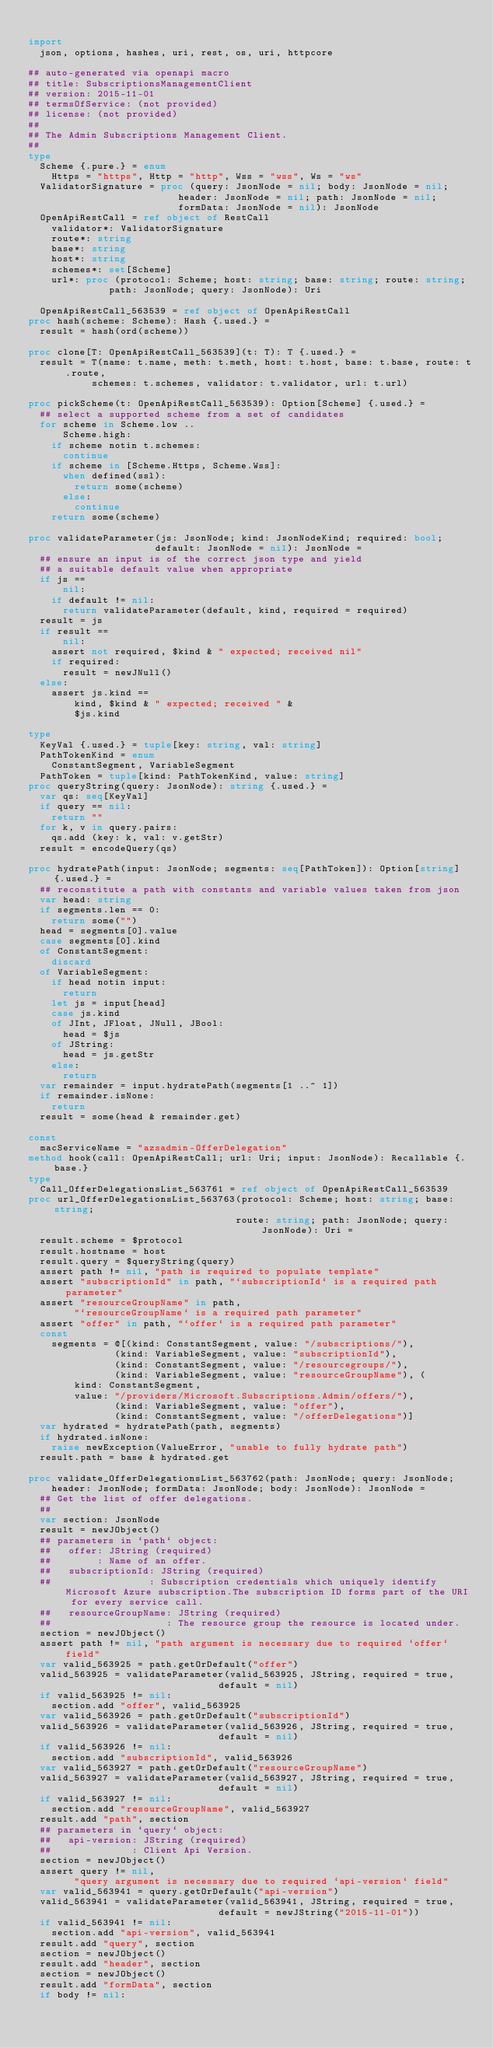<code> <loc_0><loc_0><loc_500><loc_500><_Nim_>
import
  json, options, hashes, uri, rest, os, uri, httpcore

## auto-generated via openapi macro
## title: SubscriptionsManagementClient
## version: 2015-11-01
## termsOfService: (not provided)
## license: (not provided)
## 
## The Admin Subscriptions Management Client.
## 
type
  Scheme {.pure.} = enum
    Https = "https", Http = "http", Wss = "wss", Ws = "ws"
  ValidatorSignature = proc (query: JsonNode = nil; body: JsonNode = nil;
                          header: JsonNode = nil; path: JsonNode = nil;
                          formData: JsonNode = nil): JsonNode
  OpenApiRestCall = ref object of RestCall
    validator*: ValidatorSignature
    route*: string
    base*: string
    host*: string
    schemes*: set[Scheme]
    url*: proc (protocol: Scheme; host: string; base: string; route: string;
              path: JsonNode; query: JsonNode): Uri

  OpenApiRestCall_563539 = ref object of OpenApiRestCall
proc hash(scheme: Scheme): Hash {.used.} =
  result = hash(ord(scheme))

proc clone[T: OpenApiRestCall_563539](t: T): T {.used.} =
  result = T(name: t.name, meth: t.meth, host: t.host, base: t.base, route: t.route,
           schemes: t.schemes, validator: t.validator, url: t.url)

proc pickScheme(t: OpenApiRestCall_563539): Option[Scheme] {.used.} =
  ## select a supported scheme from a set of candidates
  for scheme in Scheme.low ..
      Scheme.high:
    if scheme notin t.schemes:
      continue
    if scheme in [Scheme.Https, Scheme.Wss]:
      when defined(ssl):
        return some(scheme)
      else:
        continue
    return some(scheme)

proc validateParameter(js: JsonNode; kind: JsonNodeKind; required: bool;
                      default: JsonNode = nil): JsonNode =
  ## ensure an input is of the correct json type and yield
  ## a suitable default value when appropriate
  if js ==
      nil:
    if default != nil:
      return validateParameter(default, kind, required = required)
  result = js
  if result ==
      nil:
    assert not required, $kind & " expected; received nil"
    if required:
      result = newJNull()
  else:
    assert js.kind ==
        kind, $kind & " expected; received " &
        $js.kind

type
  KeyVal {.used.} = tuple[key: string, val: string]
  PathTokenKind = enum
    ConstantSegment, VariableSegment
  PathToken = tuple[kind: PathTokenKind, value: string]
proc queryString(query: JsonNode): string {.used.} =
  var qs: seq[KeyVal]
  if query == nil:
    return ""
  for k, v in query.pairs:
    qs.add (key: k, val: v.getStr)
  result = encodeQuery(qs)

proc hydratePath(input: JsonNode; segments: seq[PathToken]): Option[string] {.used.} =
  ## reconstitute a path with constants and variable values taken from json
  var head: string
  if segments.len == 0:
    return some("")
  head = segments[0].value
  case segments[0].kind
  of ConstantSegment:
    discard
  of VariableSegment:
    if head notin input:
      return
    let js = input[head]
    case js.kind
    of JInt, JFloat, JNull, JBool:
      head = $js
    of JString:
      head = js.getStr
    else:
      return
  var remainder = input.hydratePath(segments[1 ..^ 1])
  if remainder.isNone:
    return
  result = some(head & remainder.get)

const
  macServiceName = "azsadmin-OfferDelegation"
method hook(call: OpenApiRestCall; url: Uri; input: JsonNode): Recallable {.base.}
type
  Call_OfferDelegationsList_563761 = ref object of OpenApiRestCall_563539
proc url_OfferDelegationsList_563763(protocol: Scheme; host: string; base: string;
                                    route: string; path: JsonNode; query: JsonNode): Uri =
  result.scheme = $protocol
  result.hostname = host
  result.query = $queryString(query)
  assert path != nil, "path is required to populate template"
  assert "subscriptionId" in path, "`subscriptionId` is a required path parameter"
  assert "resourceGroupName" in path,
        "`resourceGroupName` is a required path parameter"
  assert "offer" in path, "`offer` is a required path parameter"
  const
    segments = @[(kind: ConstantSegment, value: "/subscriptions/"),
               (kind: VariableSegment, value: "subscriptionId"),
               (kind: ConstantSegment, value: "/resourcegroups/"),
               (kind: VariableSegment, value: "resourceGroupName"), (
        kind: ConstantSegment,
        value: "/providers/Microsoft.Subscriptions.Admin/offers/"),
               (kind: VariableSegment, value: "offer"),
               (kind: ConstantSegment, value: "/offerDelegations")]
  var hydrated = hydratePath(path, segments)
  if hydrated.isNone:
    raise newException(ValueError, "unable to fully hydrate path")
  result.path = base & hydrated.get

proc validate_OfferDelegationsList_563762(path: JsonNode; query: JsonNode;
    header: JsonNode; formData: JsonNode; body: JsonNode): JsonNode =
  ## Get the list of offer delegations.
  ## 
  var section: JsonNode
  result = newJObject()
  ## parameters in `path` object:
  ##   offer: JString (required)
  ##        : Name of an offer.
  ##   subscriptionId: JString (required)
  ##                 : Subscription credentials which uniquely identify Microsoft Azure subscription.The subscription ID forms part of the URI for every service call.
  ##   resourceGroupName: JString (required)
  ##                    : The resource group the resource is located under.
  section = newJObject()
  assert path != nil, "path argument is necessary due to required `offer` field"
  var valid_563925 = path.getOrDefault("offer")
  valid_563925 = validateParameter(valid_563925, JString, required = true,
                                 default = nil)
  if valid_563925 != nil:
    section.add "offer", valid_563925
  var valid_563926 = path.getOrDefault("subscriptionId")
  valid_563926 = validateParameter(valid_563926, JString, required = true,
                                 default = nil)
  if valid_563926 != nil:
    section.add "subscriptionId", valid_563926
  var valid_563927 = path.getOrDefault("resourceGroupName")
  valid_563927 = validateParameter(valid_563927, JString, required = true,
                                 default = nil)
  if valid_563927 != nil:
    section.add "resourceGroupName", valid_563927
  result.add "path", section
  ## parameters in `query` object:
  ##   api-version: JString (required)
  ##              : Client Api Version.
  section = newJObject()
  assert query != nil,
        "query argument is necessary due to required `api-version` field"
  var valid_563941 = query.getOrDefault("api-version")
  valid_563941 = validateParameter(valid_563941, JString, required = true,
                                 default = newJString("2015-11-01"))
  if valid_563941 != nil:
    section.add "api-version", valid_563941
  result.add "query", section
  section = newJObject()
  result.add "header", section
  section = newJObject()
  result.add "formData", section
  if body != nil:</code> 